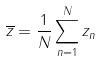<formula> <loc_0><loc_0><loc_500><loc_500>\overline { z } = \frac { 1 } { N } \sum _ { n = 1 } ^ { N } z _ { n }</formula> 